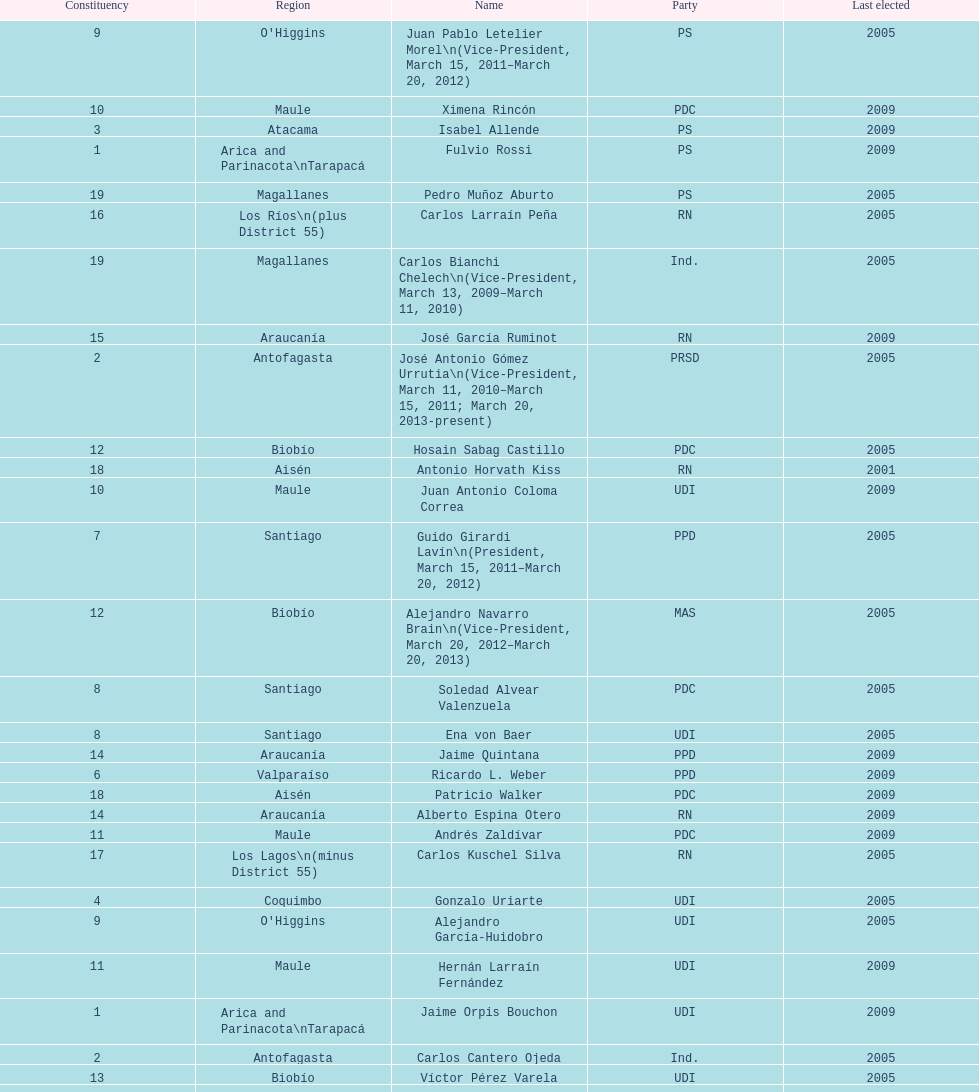How long was baldo prokurica prokurica vice-president? 1 year. 